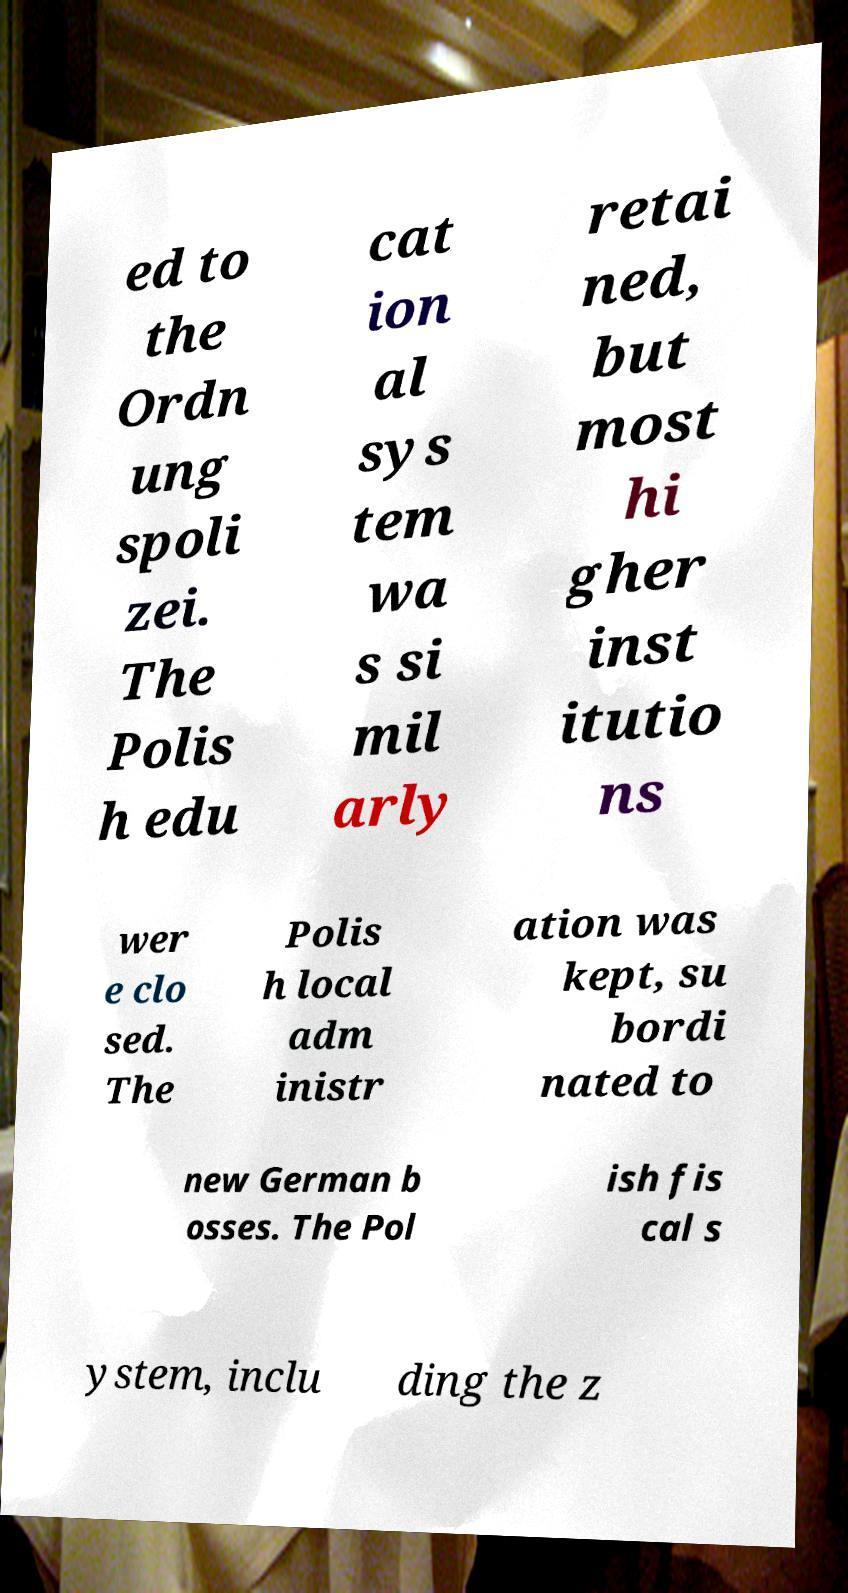Could you extract and type out the text from this image? ed to the Ordn ung spoli zei. The Polis h edu cat ion al sys tem wa s si mil arly retai ned, but most hi gher inst itutio ns wer e clo sed. The Polis h local adm inistr ation was kept, su bordi nated to new German b osses. The Pol ish fis cal s ystem, inclu ding the z 